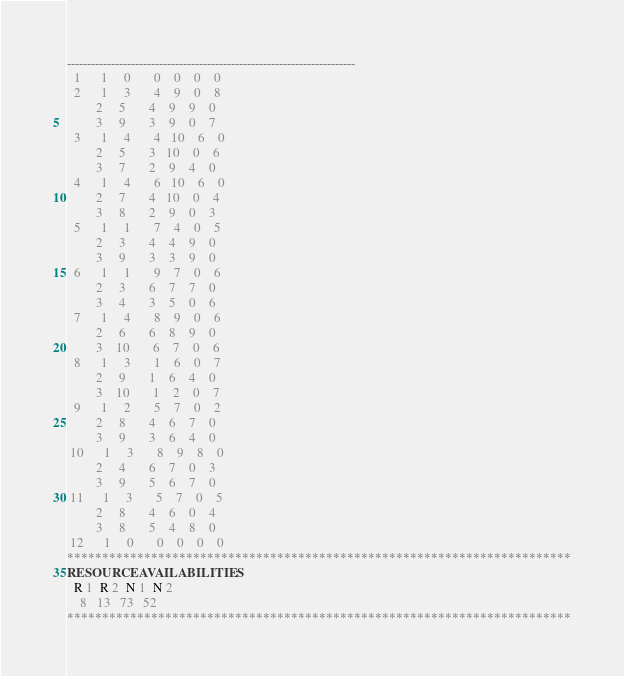Convert code to text. <code><loc_0><loc_0><loc_500><loc_500><_ObjectiveC_>------------------------------------------------------------------------
  1      1     0       0    0    0    0
  2      1     3       4    9    0    8
         2     5       4    9    9    0
         3     9       3    9    0    7
  3      1     4       4   10    6    0
         2     5       3   10    0    6
         3     7       2    9    4    0
  4      1     4       6   10    6    0
         2     7       4   10    0    4
         3     8       2    9    0    3
  5      1     1       7    4    0    5
         2     3       4    4    9    0
         3     9       3    3    9    0
  6      1     1       9    7    0    6
         2     3       6    7    7    0
         3     4       3    5    0    6
  7      1     4       8    9    0    6
         2     6       6    8    9    0
         3    10       6    7    0    6
  8      1     3       1    6    0    7
         2     9       1    6    4    0
         3    10       1    2    0    7
  9      1     2       5    7    0    2
         2     8       4    6    7    0
         3     9       3    6    4    0
 10      1     3       8    9    8    0
         2     4       6    7    0    3
         3     9       5    6    7    0
 11      1     3       5    7    0    5
         2     8       4    6    0    4
         3     8       5    4    8    0
 12      1     0       0    0    0    0
************************************************************************
RESOURCEAVAILABILITIES:
  R 1  R 2  N 1  N 2
    8   13   73   52
************************************************************************
</code> 